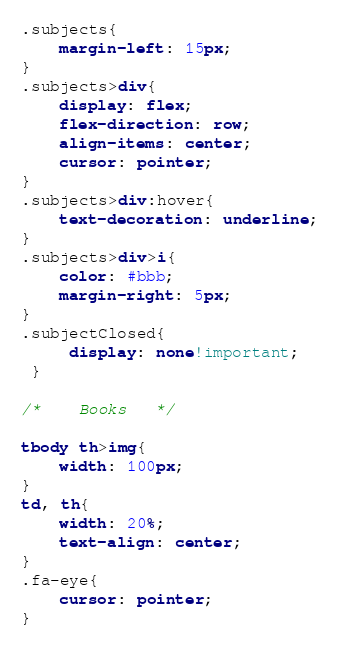<code> <loc_0><loc_0><loc_500><loc_500><_CSS_>.subjects{
    margin-left: 15px;
}
.subjects>div{
    display: flex;
    flex-direction: row;
    align-items: center;
    cursor: pointer;
}
.subjects>div:hover{
    text-decoration: underline;
}
.subjects>div>i{
    color: #bbb;
    margin-right: 5px;
}
.subjectClosed{
     display: none!important;
 }

/*    Books   */

tbody th>img{
    width: 100px;
}
td, th{
    width: 20%;
    text-align: center;
}
.fa-eye{
    cursor: pointer;
}</code> 